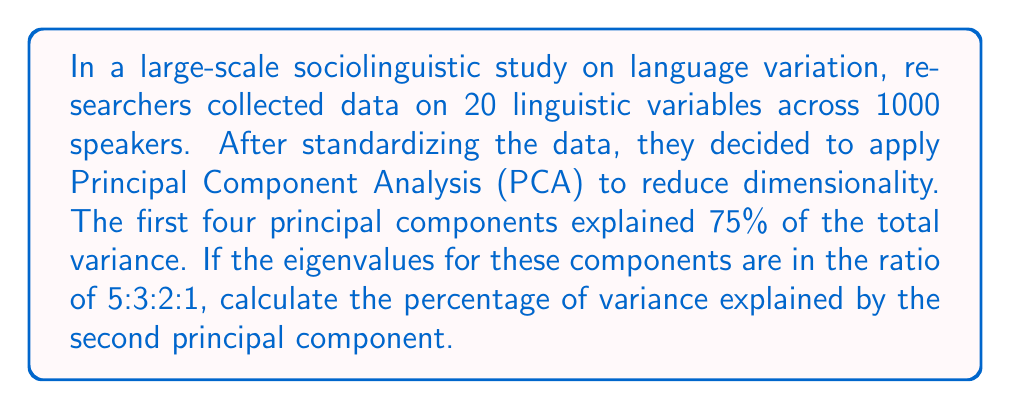Provide a solution to this math problem. To solve this problem, we need to follow these steps:

1) First, let's define our variables:
   Let $\lambda_1, \lambda_2, \lambda_3, \lambda_4$ be the eigenvalues of the first four principal components.

2) We know that the ratio of these eigenvalues is 5:3:2:1. We can express this as:
   $\lambda_1 : \lambda_2 : \lambda_3 : \lambda_4 = 5k : 3k : 2k : k$
   where $k$ is some constant.

3) The total variance explained by these four components is 75% of the total variance. In PCA, the variance explained by each component is proportional to its eigenvalue. So:

   $\frac{\lambda_1 + \lambda_2 + \lambda_3 + \lambda_4}{\text{Total Variance}} = 0.75$

4) Substituting our ratio:
   $\frac{5k + 3k + 2k + k}{\text{Total Variance}} = 0.75$
   $\frac{11k}{\text{Total Variance}} = 0.75$

5) The variance explained by the second principal component is:
   $\frac{\lambda_2}{\text{Total Variance}} = \frac{3k}{\text{Total Variance}}$

6) We can express this in terms of the total explained variance:
   $\frac{3k}{\text{Total Variance}} = \frac{3k}{11k} \cdot \frac{11k}{\text{Total Variance}} = \frac{3}{11} \cdot 0.75$

7) Calculate the final percentage:
   $\frac{3}{11} \cdot 0.75 \cdot 100\% = 20.45\%$
Answer: The second principal component explains approximately 20.45% of the total variance. 